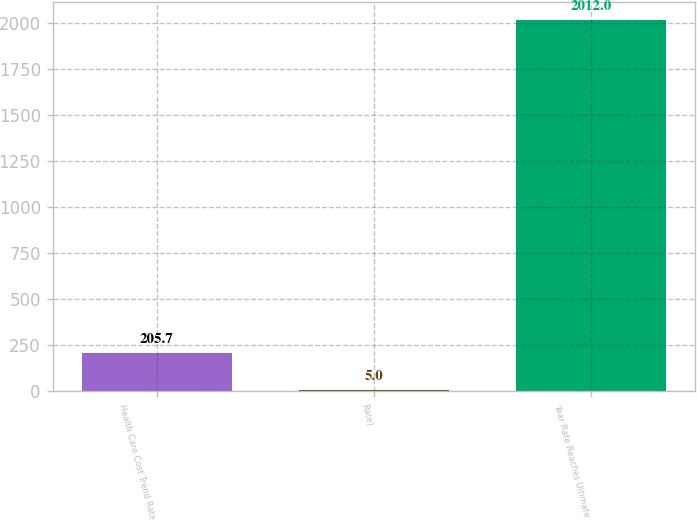<chart> <loc_0><loc_0><loc_500><loc_500><bar_chart><fcel>Health Care Cost Trend Rate<fcel>Rate)<fcel>Year Rate Reaches Ultimate<nl><fcel>205.7<fcel>5<fcel>2012<nl></chart> 